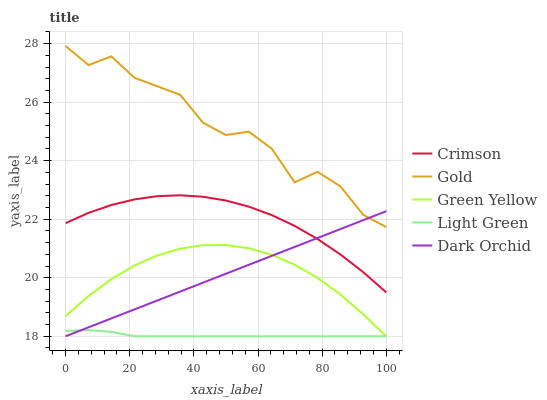Does Light Green have the minimum area under the curve?
Answer yes or no. Yes. Does Gold have the maximum area under the curve?
Answer yes or no. Yes. Does Dark Orchid have the minimum area under the curve?
Answer yes or no. No. Does Dark Orchid have the maximum area under the curve?
Answer yes or no. No. Is Dark Orchid the smoothest?
Answer yes or no. Yes. Is Gold the roughest?
Answer yes or no. Yes. Is Green Yellow the smoothest?
Answer yes or no. No. Is Green Yellow the roughest?
Answer yes or no. No. Does Dark Orchid have the lowest value?
Answer yes or no. Yes. Does Gold have the lowest value?
Answer yes or no. No. Does Gold have the highest value?
Answer yes or no. Yes. Does Dark Orchid have the highest value?
Answer yes or no. No. Is Green Yellow less than Crimson?
Answer yes or no. Yes. Is Gold greater than Green Yellow?
Answer yes or no. Yes. Does Gold intersect Dark Orchid?
Answer yes or no. Yes. Is Gold less than Dark Orchid?
Answer yes or no. No. Is Gold greater than Dark Orchid?
Answer yes or no. No. Does Green Yellow intersect Crimson?
Answer yes or no. No. 